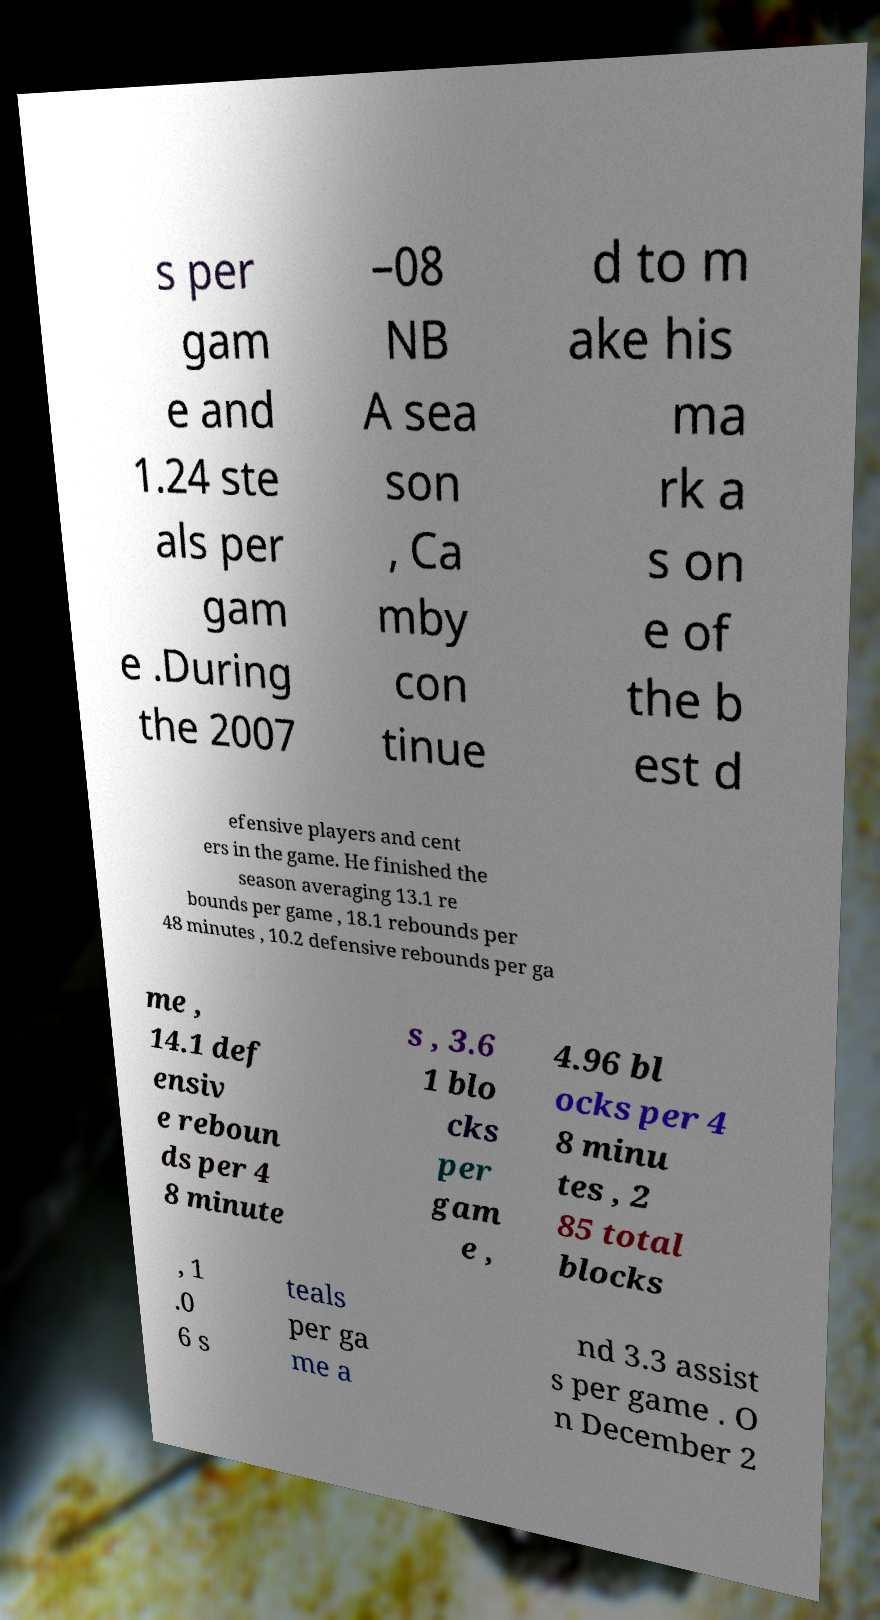Could you extract and type out the text from this image? s per gam e and 1.24 ste als per gam e .During the 2007 –08 NB A sea son , Ca mby con tinue d to m ake his ma rk a s on e of the b est d efensive players and cent ers in the game. He finished the season averaging 13.1 re bounds per game , 18.1 rebounds per 48 minutes , 10.2 defensive rebounds per ga me , 14.1 def ensiv e reboun ds per 4 8 minute s , 3.6 1 blo cks per gam e , 4.96 bl ocks per 4 8 minu tes , 2 85 total blocks , 1 .0 6 s teals per ga me a nd 3.3 assist s per game . O n December 2 